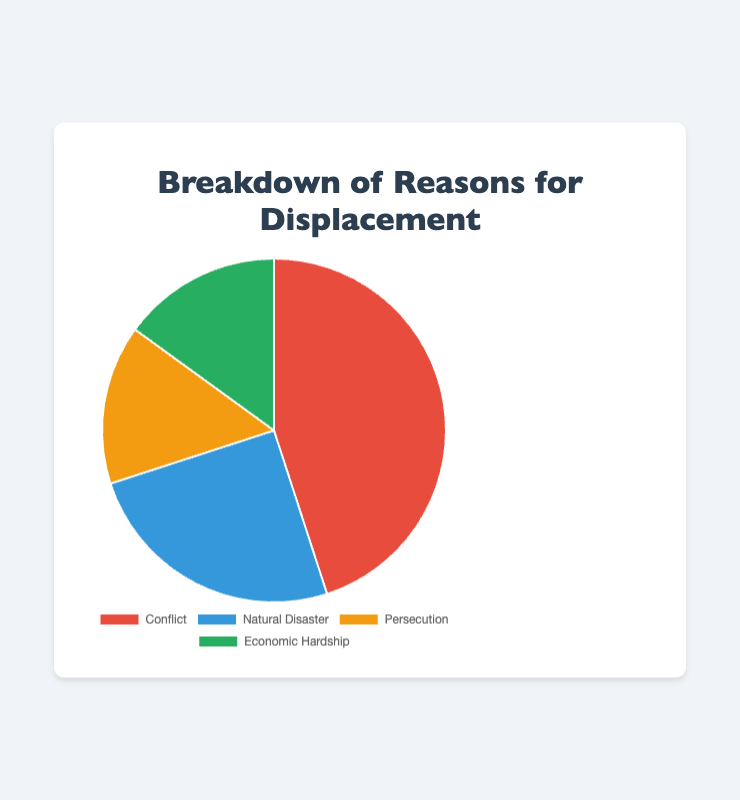What is the most common reason for displacement? By looking at the pie chart, the segment for "Conflict" is the largest, making it the most common reason for displacement.
Answer: Conflict Which two reasons for displacement are equally represented? According to the pie chart, both "Persecution" and "Economic Hardship" occupy the same size slices, each contributing 15% of the overall reasons for displacement.
Answer: Persecution and Economic Hardship What is the combined percentage of displacement due to Natural Disaster and Economic Hardship? By referring to the chart, the percentage for Natural Disaster is 25% and for Economic Hardship is 15%. Adding these together, 25% + 15% = 40%.
Answer: 40% How much larger is the percentage of displacement due to Conflict compared to Persecution? From the chart, Conflict accounts for 45% of displacement and Persecution accounts for 15%. The difference is calculated by 45% - 15% = 30%.
Answer: 30% Which reason has the second highest percentage of displacement? The chart shows that "Natural Disaster" has the second largest segment, which is 25% after "Conflict".
Answer: Natural Disaster If we combined the percentages of Persecution and Economic Hardship, where would it rank among the reasons for displacement? Combining the percentages from the chart for Persecution (15%) and Economic Hardship (15%) gives 30%. This combined value would rank second after Conflict (45%) and before Natural Disaster (25%).
Answer: Second What percentage of displacements are caused by either Conflict or Persecution? According to the chart, Conflict contributes 45% and Persecution contributes 15%. Adding these together results in 45% + 15% = 60%.
Answer: 60% Which color represents the reason with the smallest percentage for displacement? From the chart, "Persecution" and "Economic Hardship" both have the smallest slices, each 15%, and they are represented in yellow and green respectively.
Answer: Yellow and green Is the percentage of displacement due to Economic Hardship greater than the percentage due to Natural Disaster? The pie chart shows that Economic Hardship accounts for 15% while Natural Disaster accounts for 25%, so Economic Hardship is not greater than Natural Disaster.
Answer: No How does the visual size of the Natural Disaster segment compare to the Persecution segment? The chart visually represents "Natural Disaster" as a larger segment than "Persecution". Natural Disaster is 25% and Persecution is 15%.
Answer: Larger 